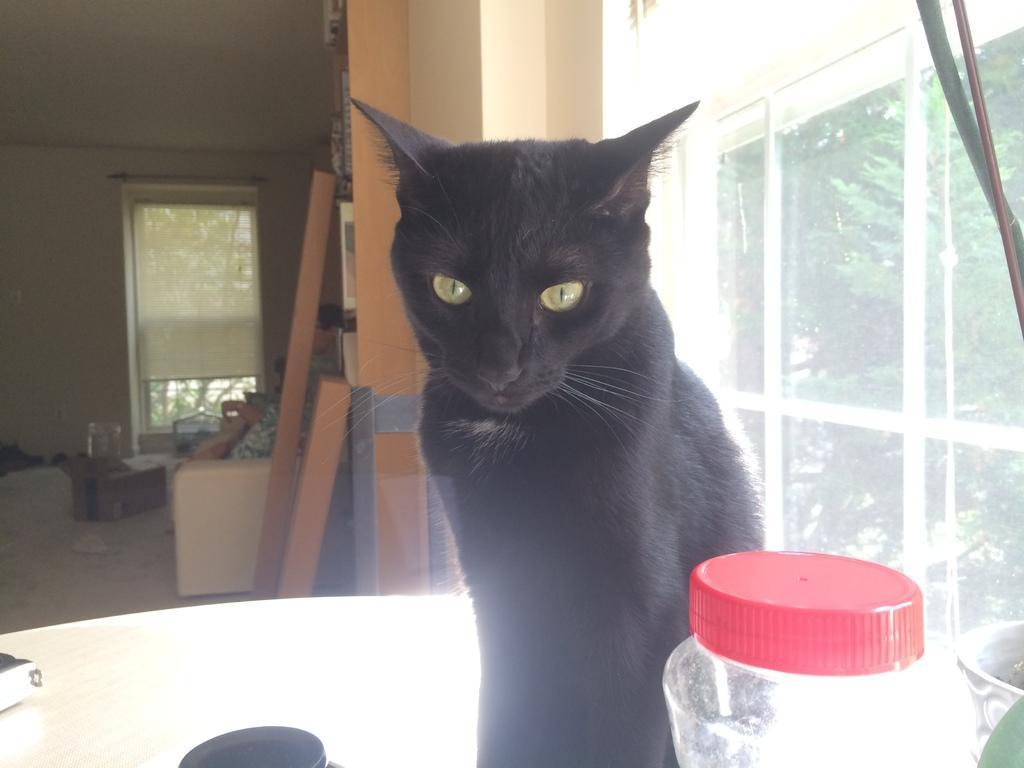Describe this image in one or two sentences. In this picture we can see a cat on the table. This is bottle. Here we can see a glass and there are trees. On the background there is a wall and this is door. 